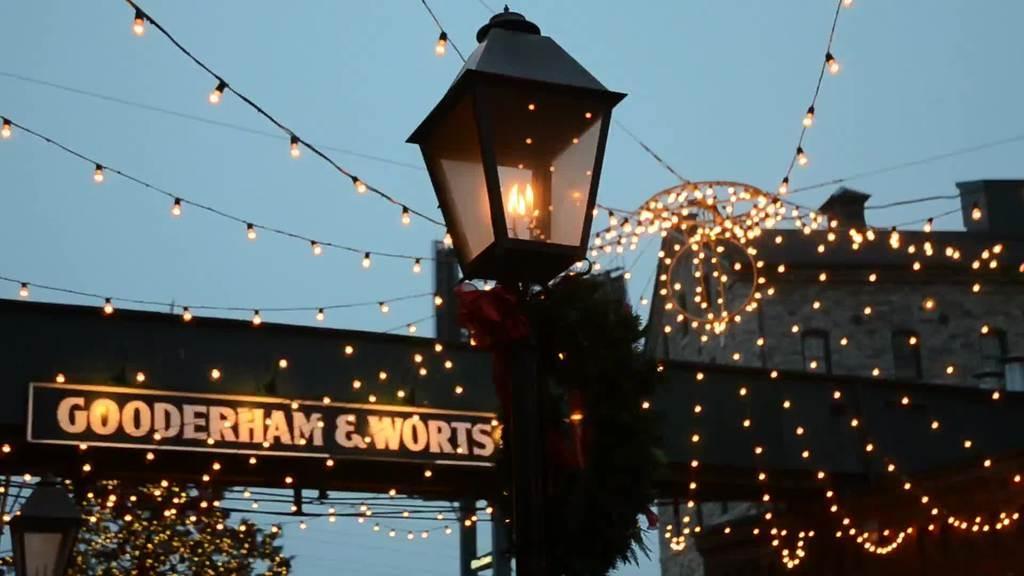Could you give a brief overview of what you see in this image? This picture shows a pole light and we see few serial lights and we see a hoarding and a building and we see a tree and a blue sky. 